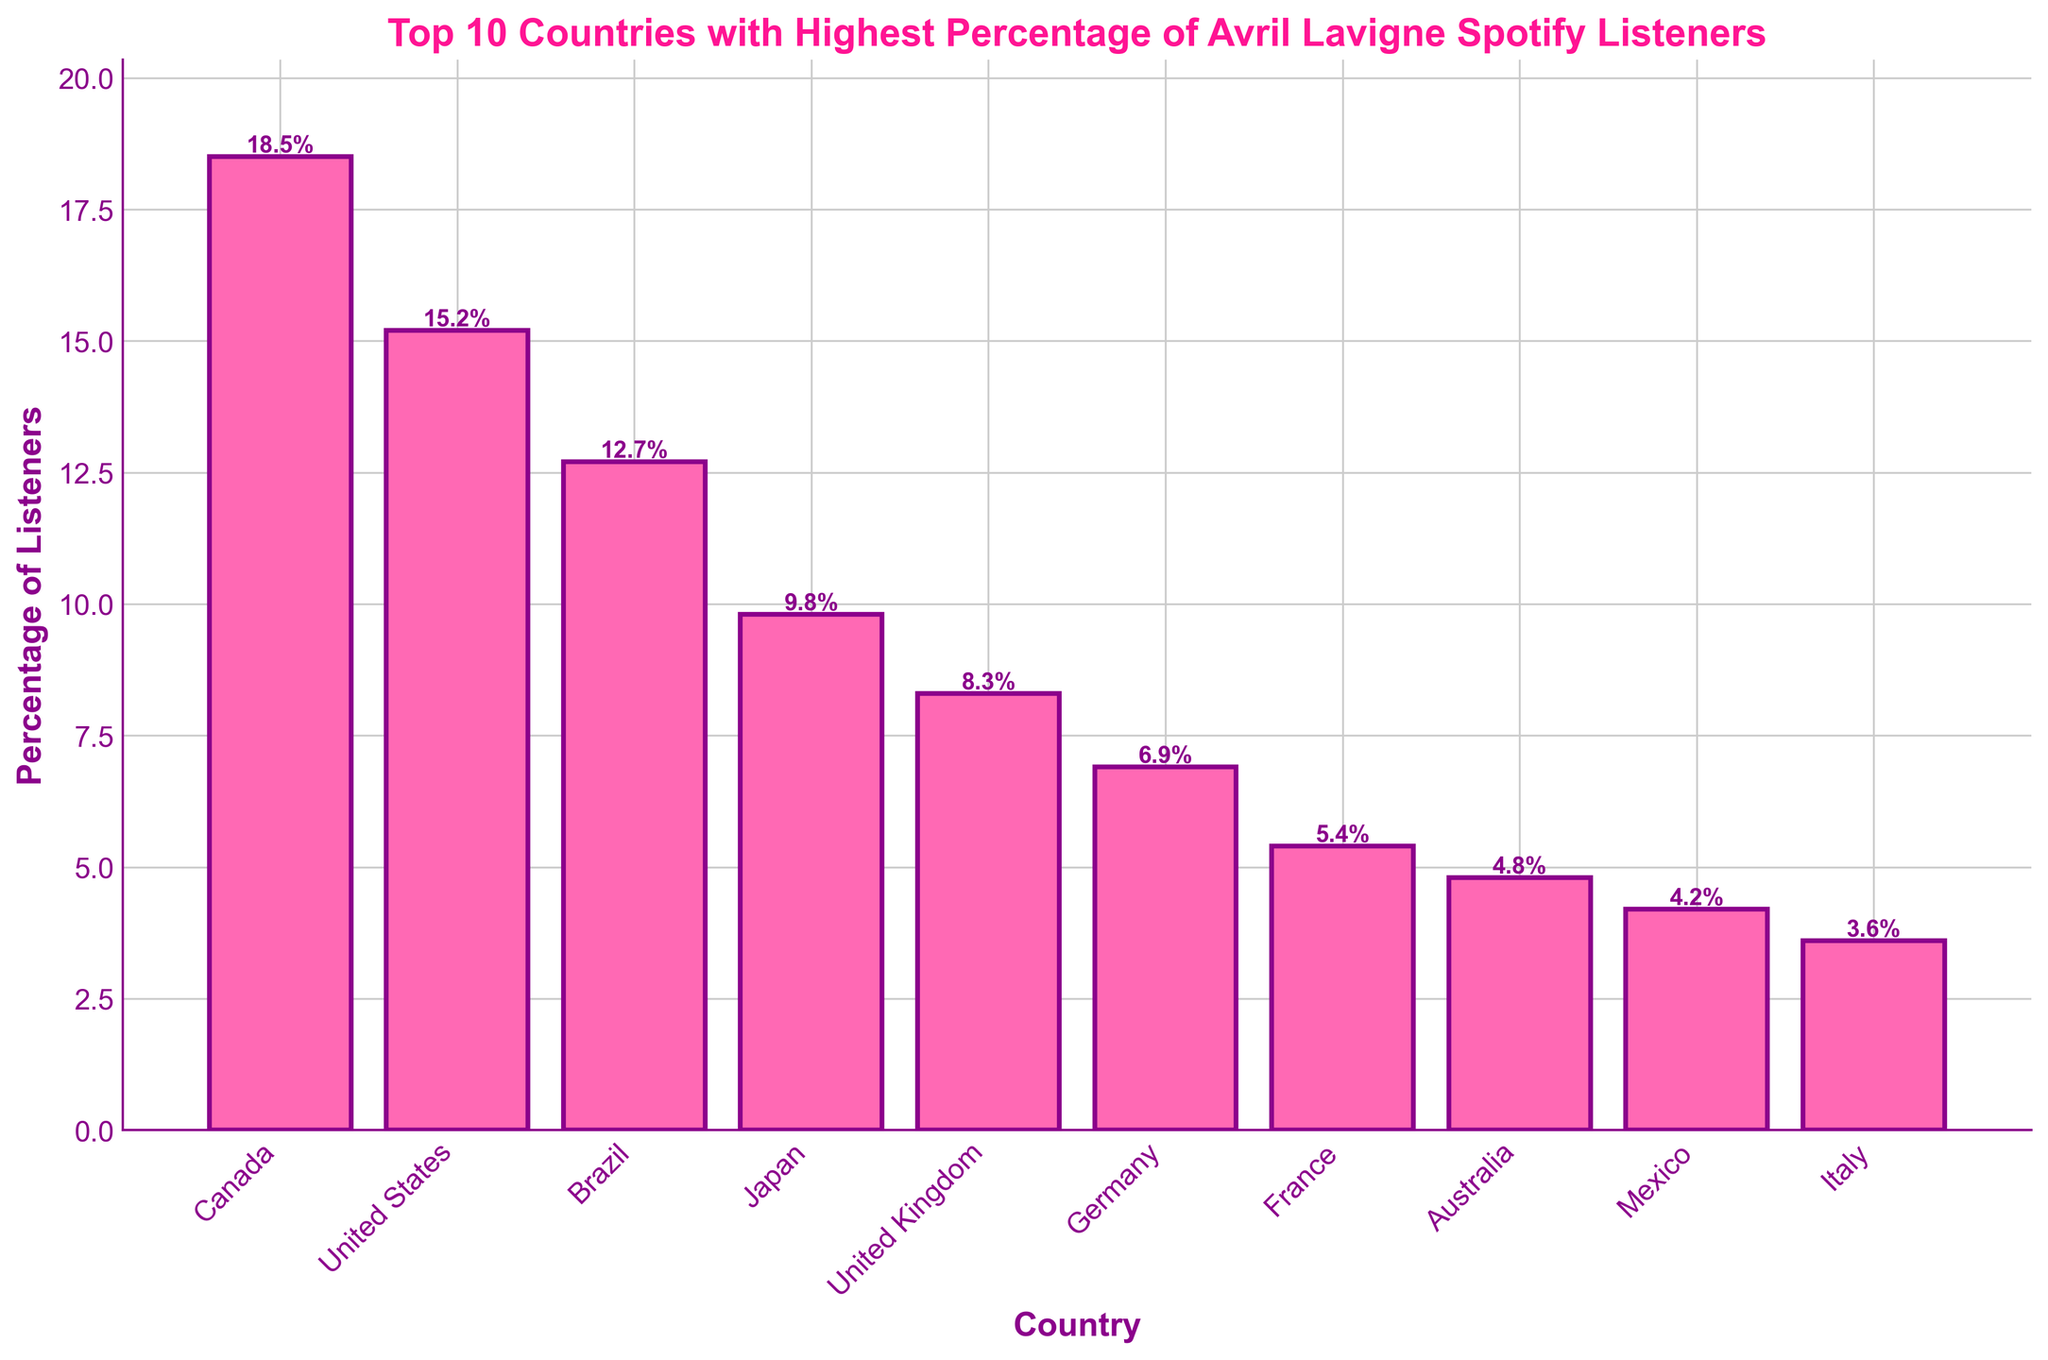Which country has the highest percentage of Avril Lavigne Spotify listeners? Look at the bar with the greatest height. Canada has the tallest bar at 18.5%. Thus, Canada has the highest percentage.
Answer: Canada Which country has the lowest percentage of Avril Lavigne Spotify listeners among the top 10? Look at the bar with the shortest height. Italy has the shortest bar at 3.6%. Therefore, Italy has the lowest percentage.
Answer: Italy How many countries have a percentage of listeners greater than 10%? Count the bars that extend beyond the 10% mark. Canada, United States, and Brazil all have percentages above 10%. Thus, three countries have more than 10%.
Answer: 3 What's the average percentage of listeners for the countries in the top 5? Add the percentages of the top 5 countries and divide by 5. (18.5 + 15.2 + 12.7 + 9.8 + 8.3) / 5 = 64.5 / 5 = 12.9%. The average is 12.9%.
Answer: 12.9% Which countries have a higher percentage of Avril Lavigne listeners than Germany but lower than Japan? Identify countries whose bars are taller than Germany (6.9%) and shorter than Japan (9.8%). The United Kingdom (8.3%) and Brazil (12.7%) fit this criterion. The United Kingdom is the correct answer.
Answer: United Kingdom What is the total percentage of listeners in the top 3 countries combined? Sum the percentages of Canada, United States, and Brazil. 18.5 + 15.2 + 12.7 = 46.4%. The total percentage is 46.4%.
Answer: 46.4% Which country ranks 5th in the percentage of Avril Lavigne listeners on Spotify? List the percentages in descending order and identify the 5th highest. Canada (18.5%), United States (15.2%), Brazil (12.7%), Japan (9.8%), and United Kingdom (8.3%) show that the United Kingdom ranks 5th.
Answer: United Kingdom What is the difference in percentage of listeners between the United States and France? Subtract France’s percentage from the United States'. 15.2% - 5.4% = 9.8%. The difference is 9.8%.
Answer: 9.8% What is the range of percentages of listeners in the top 10 countries? Subtract the smallest percentage from the largest percentage. 18.5% - 3.6% = 14.9%. The range is 14.9%.
Answer: 14.9% Compare the percentages of listeners for Mexico and Australia. Which country has more listeners? Look at the heights of the bars for Mexico and Australia. Australia's bar is taller at 4.8%, while Mexico's is 4.2%. Therefore, Australia has more listeners.
Answer: Australia 